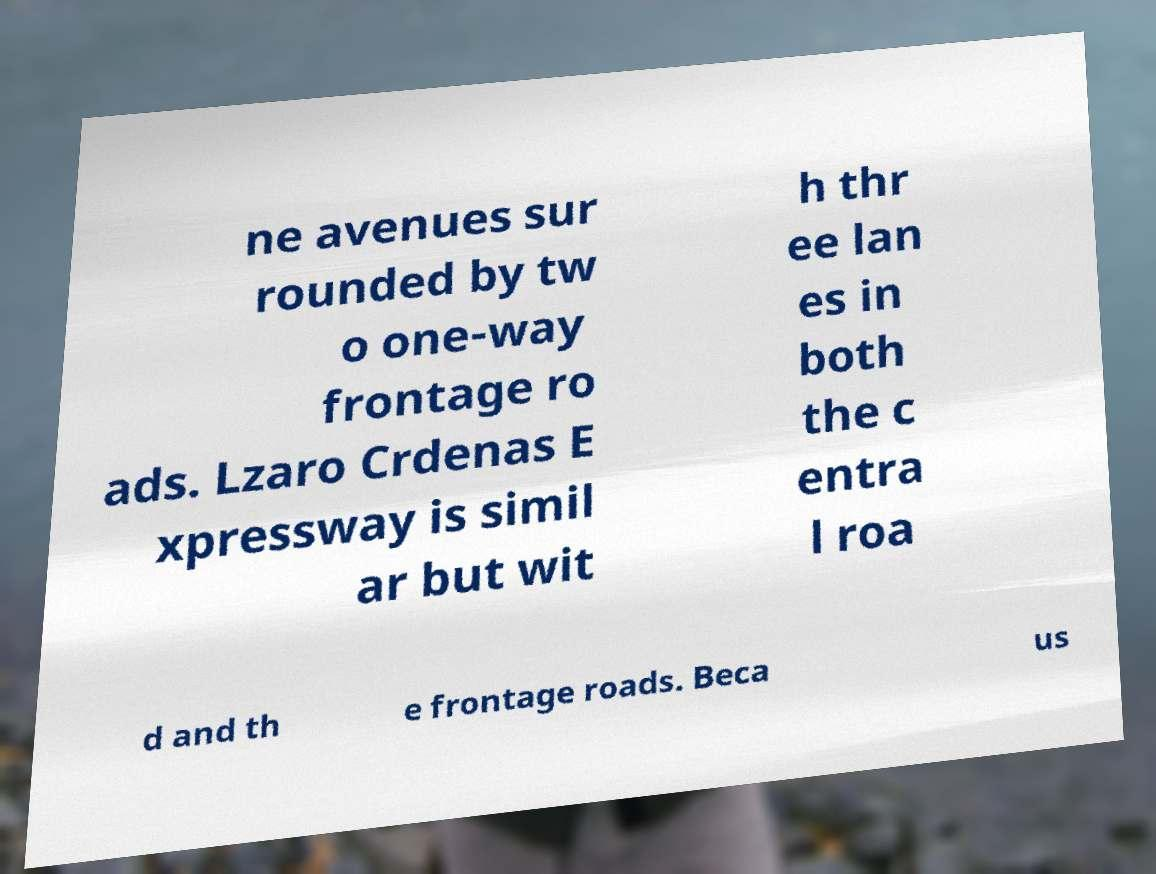Please read and relay the text visible in this image. What does it say? ne avenues sur rounded by tw o one-way frontage ro ads. Lzaro Crdenas E xpressway is simil ar but wit h thr ee lan es in both the c entra l roa d and th e frontage roads. Beca us 